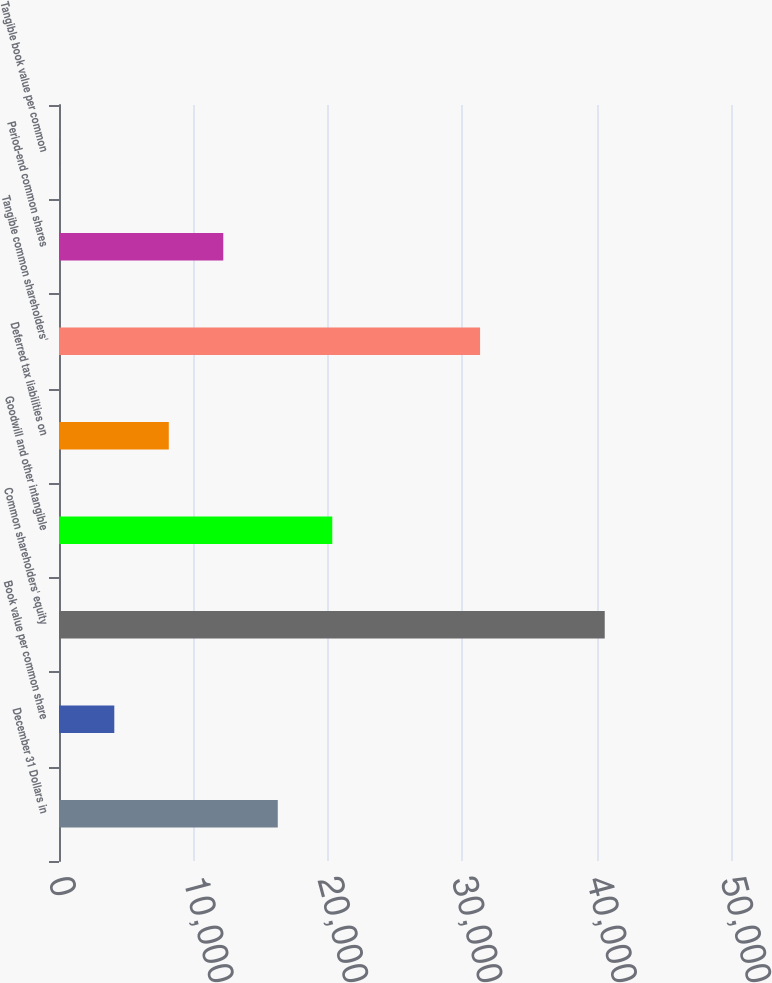Convert chart. <chart><loc_0><loc_0><loc_500><loc_500><bar_chart><fcel>December 31 Dollars in<fcel>Book value per common share<fcel>Common shareholders' equity<fcel>Goodwill and other intangible<fcel>Deferred tax liabilities on<fcel>Tangible common shareholders'<fcel>Period-end common shares<fcel>Tangible book value per common<nl><fcel>16277.9<fcel>4114.39<fcel>40605<fcel>20332.4<fcel>8168.9<fcel>31330<fcel>12223.4<fcel>59.88<nl></chart> 